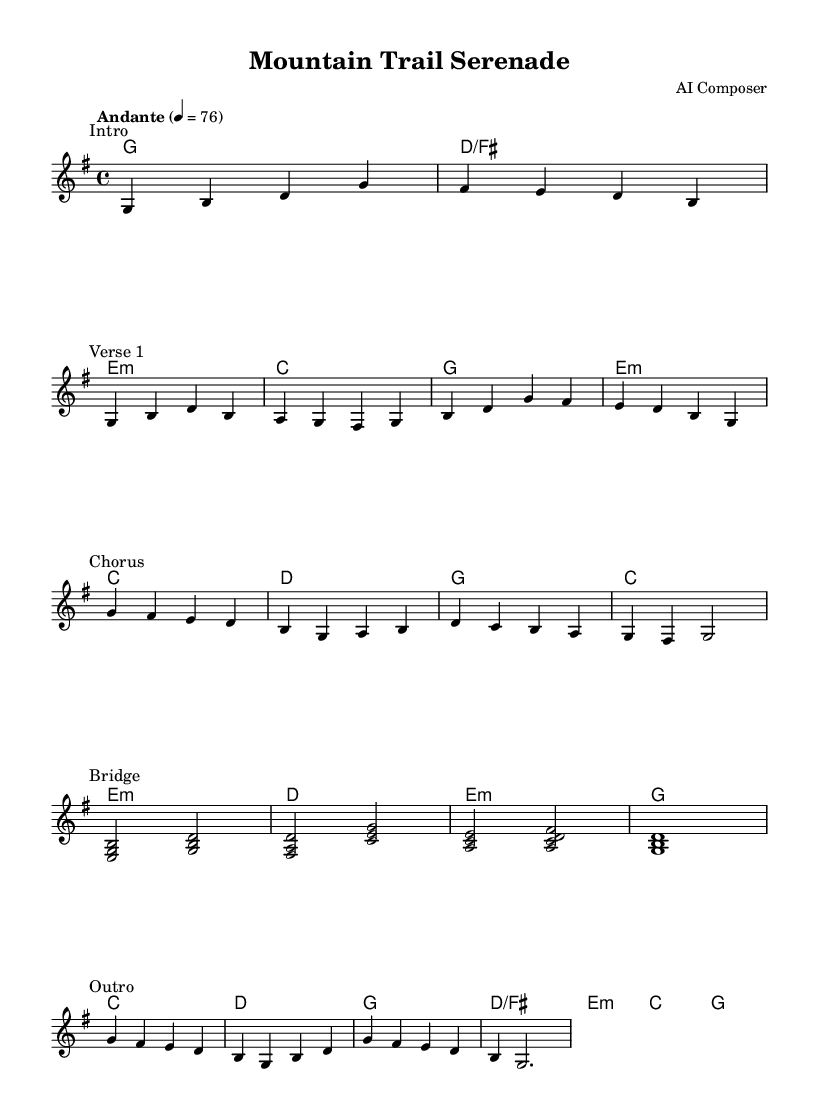What is the key signature of this music? The key signature is G major, which has one sharp (F#). This can be determined by looking at the key signature indicated at the beginning of the score.
Answer: G major What is the time signature of this music? The time signature is 4/4, which means there are four beats in a measure and the quarter note gets one beat. This is shown at the beginning of the score next to the key signature.
Answer: 4/4 What is the tempo indication for this piece? The tempo indication is Andante, with a metronome marking of 76 beats per minute. This is specified in the tempo marking found near the beginning of the score.
Answer: Andante 76 How many measures are in the Chorus section? The Chorus section consists of four measures. This can be found by counting the measures marked from the starting point of the Chorus text marking to the end of that section.
Answer: Four measures What is the primary chord used in the first measure? The primary chord in the first measure is G major, as indicated by the chord name above the first measure. This can be verified by looking at the chord indications placed above the staff.
Answer: G How many different sections are present in this piece? The piece contains five sections, specifically marked as Intro, Verse 1, Chorus, Bridge, and Outro. This can be determined by noting the different text markings throughout the score.
Answer: Five sections What are the last two notes of the Outro? The last two notes of the Outro are B and G. This can be confirmed by examining the final measure in the Outro section at the end of the score.
Answer: B and G 